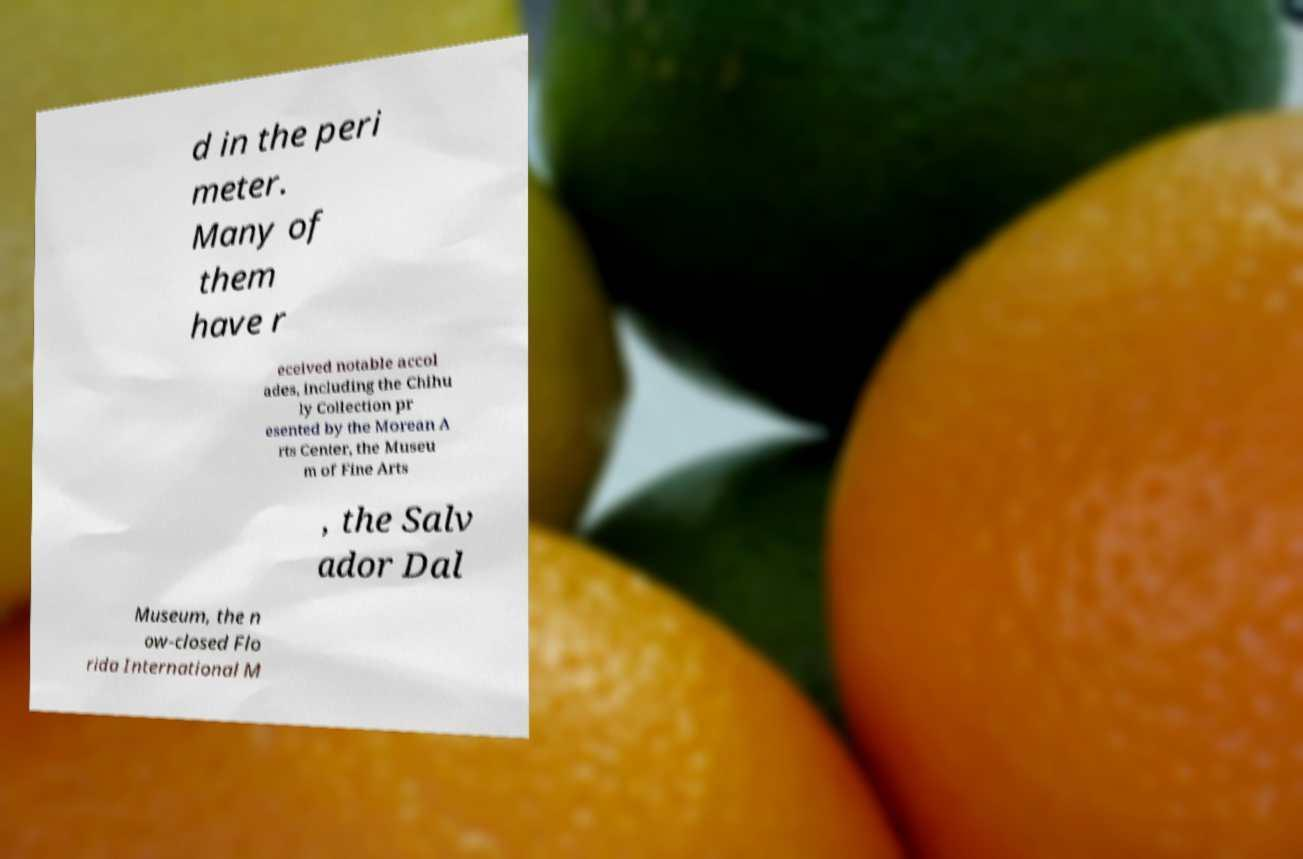Can you read and provide the text displayed in the image?This photo seems to have some interesting text. Can you extract and type it out for me? d in the peri meter. Many of them have r eceived notable accol ades, including the Chihu ly Collection pr esented by the Morean A rts Center, the Museu m of Fine Arts , the Salv ador Dal Museum, the n ow-closed Flo rida International M 